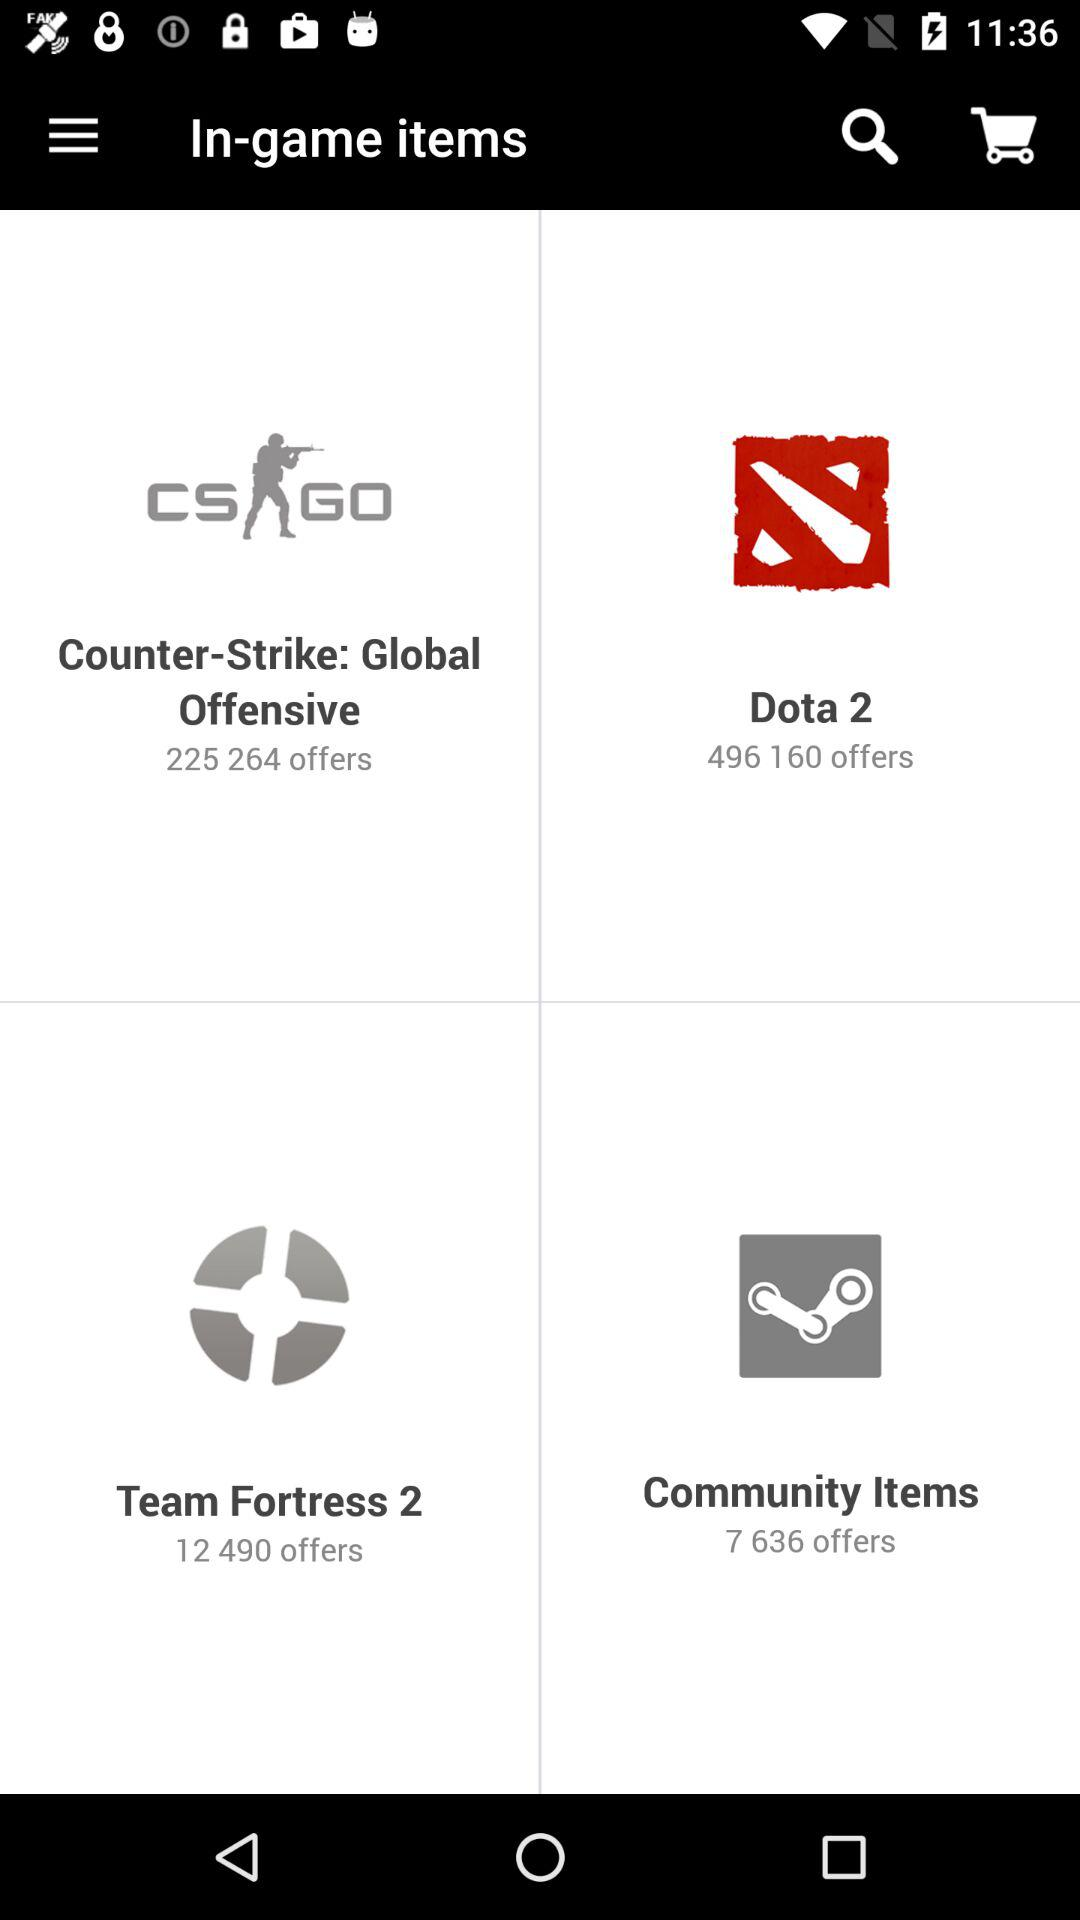What is the total number of offers in "Team Fortress 2"? The total number of offers in "Team Fortress 2" is 12490. 